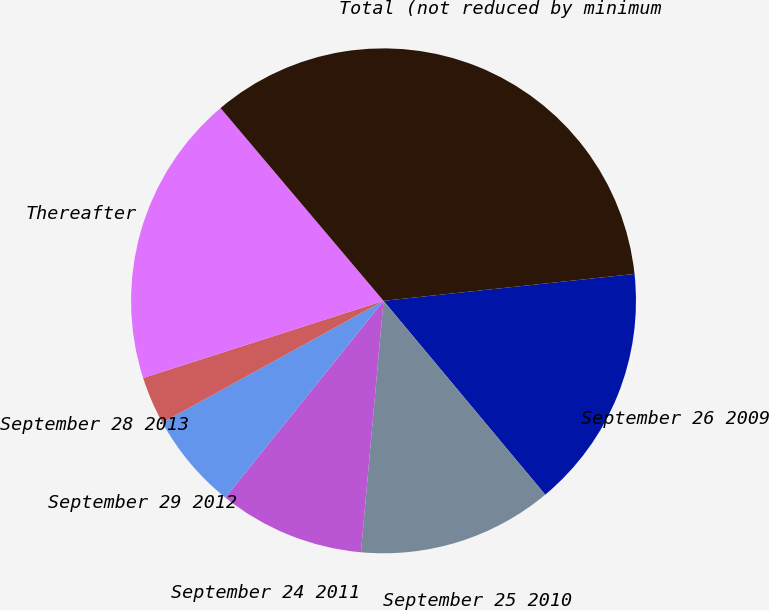Convert chart. <chart><loc_0><loc_0><loc_500><loc_500><pie_chart><fcel>September 26 2009<fcel>September 25 2010<fcel>September 24 2011<fcel>September 29 2012<fcel>September 28 2013<fcel>Thereafter<fcel>Total (not reduced by minimum<nl><fcel>15.63%<fcel>12.49%<fcel>9.35%<fcel>6.21%<fcel>3.07%<fcel>18.77%<fcel>34.47%<nl></chart> 